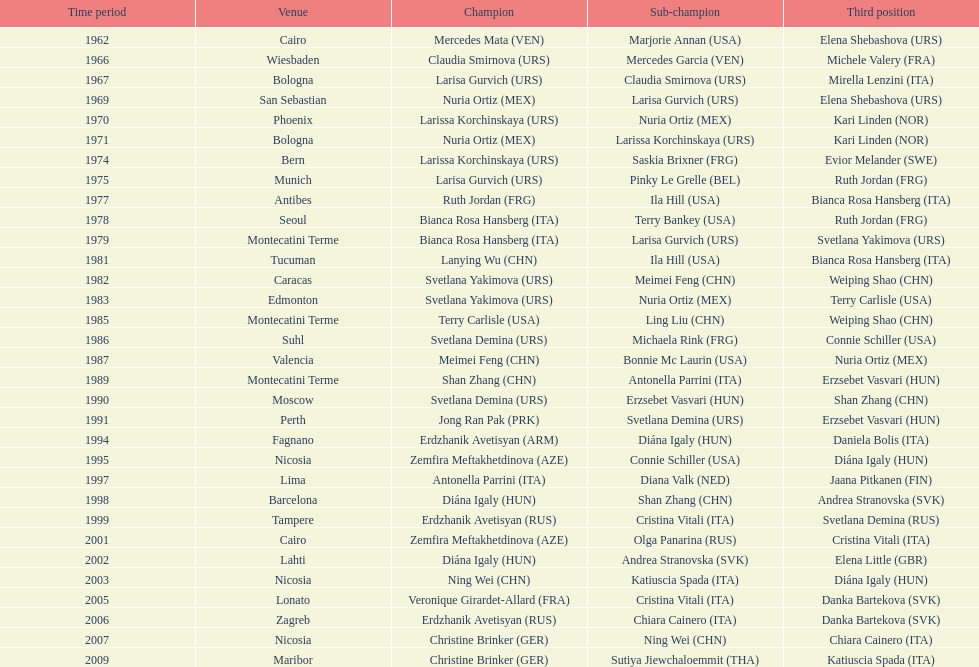Which country has the most bronze medals? Italy. 